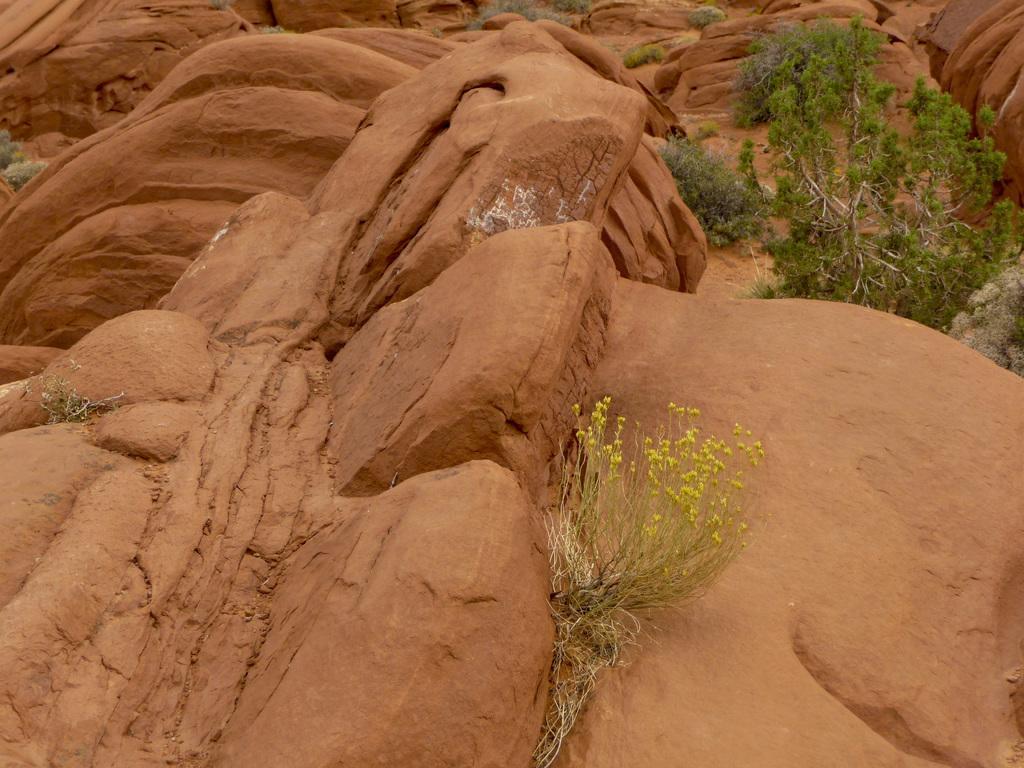Please provide a concise description of this image. In this image I can see brown colour rocks and in the front I can see a plant. In the background I can see few more plants and a tree. 